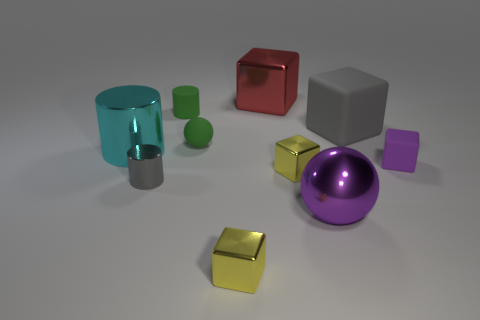There is a metallic block that is both in front of the tiny purple block and behind the purple metallic object; what is its size?
Your response must be concise. Small. What color is the ball that is made of the same material as the purple block?
Your response must be concise. Green. What number of big brown cubes have the same material as the big sphere?
Your response must be concise. 0. Are there an equal number of purple balls behind the small purple matte thing and large purple shiny balls behind the gray matte thing?
Offer a terse response. Yes. Does the large purple object have the same shape as the small thing that is left of the green matte cylinder?
Make the answer very short. No. There is a thing that is the same color as the small rubber cylinder; what is its material?
Keep it short and to the point. Rubber. Is there any other thing that is the same shape as the big gray thing?
Your answer should be compact. Yes. Is the cyan cylinder made of the same material as the ball that is behind the cyan metal cylinder?
Give a very brief answer. No. There is a small object that is in front of the sphere in front of the small yellow cube that is behind the big ball; what color is it?
Your answer should be compact. Yellow. Is there any other thing that has the same size as the gray matte block?
Give a very brief answer. Yes. 